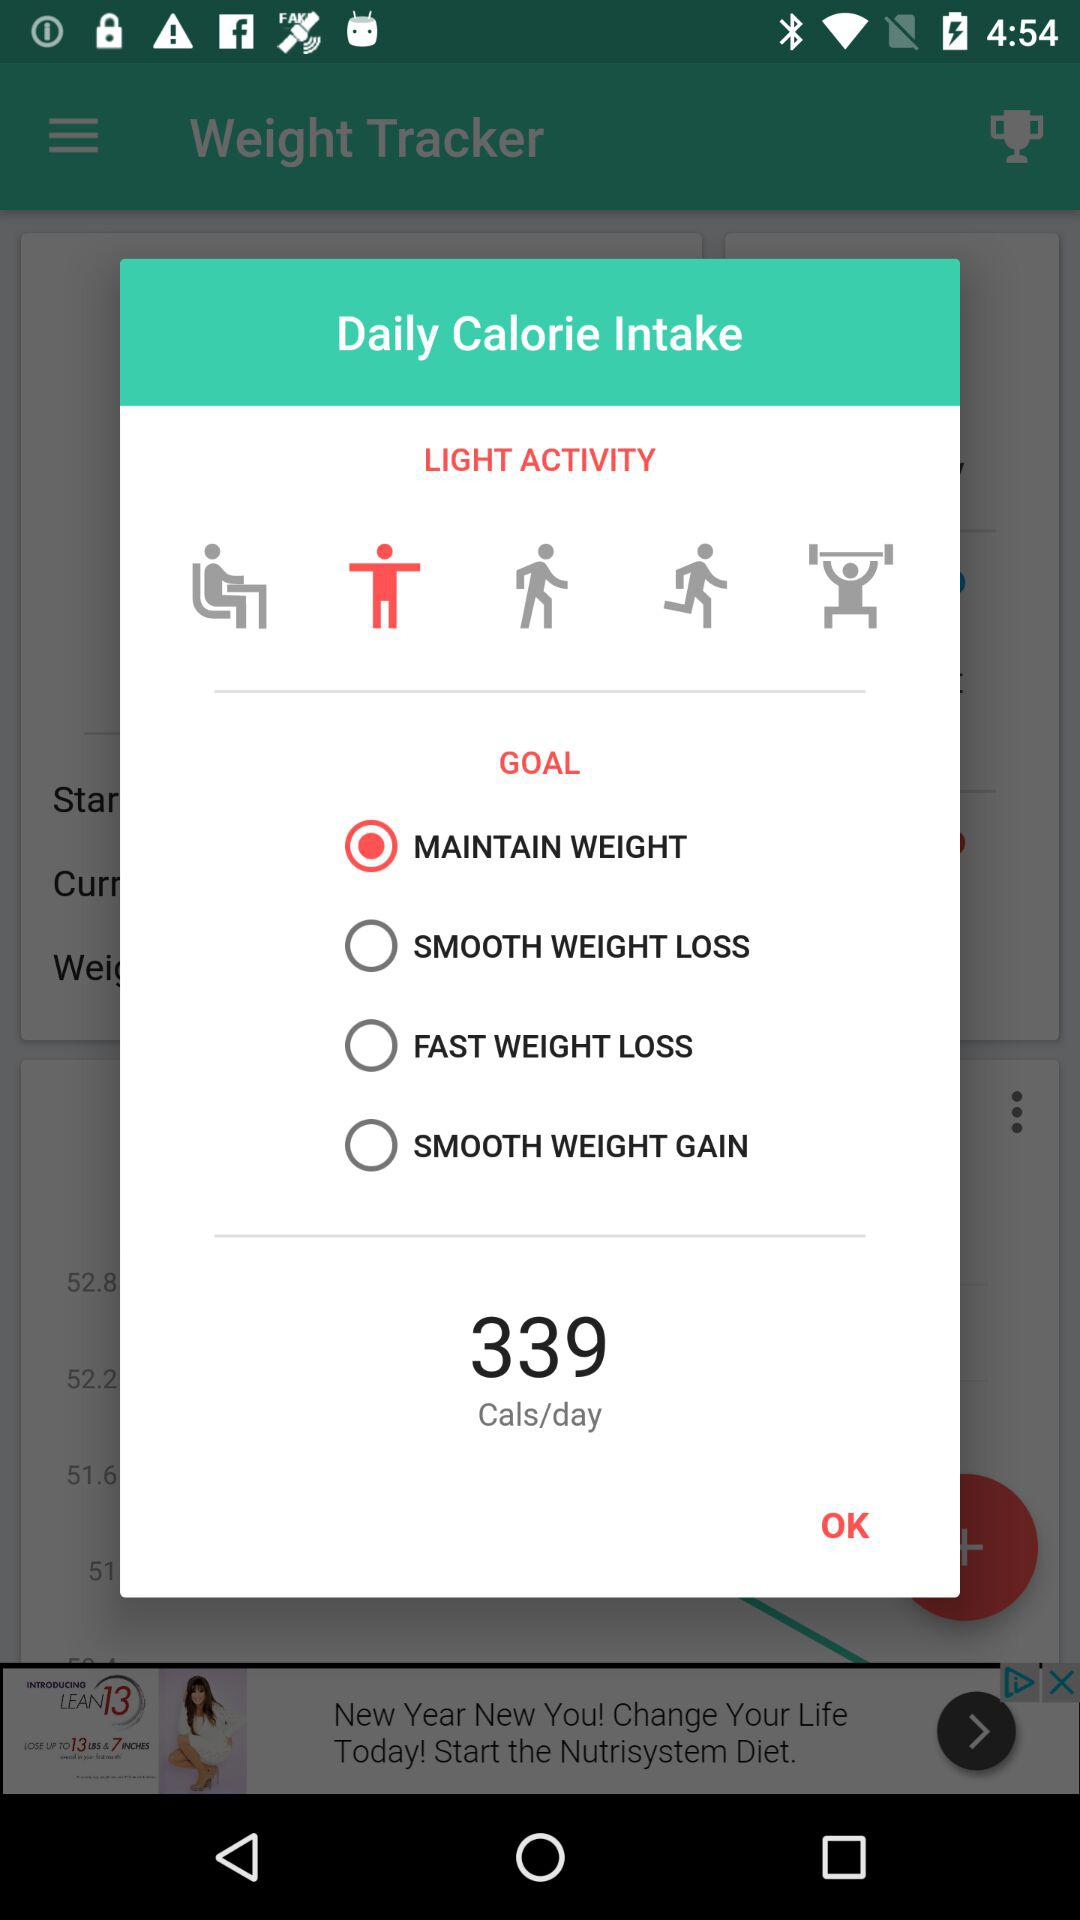What is the selected goal? The selected goal is "MAINTAIN WEIGHT". 